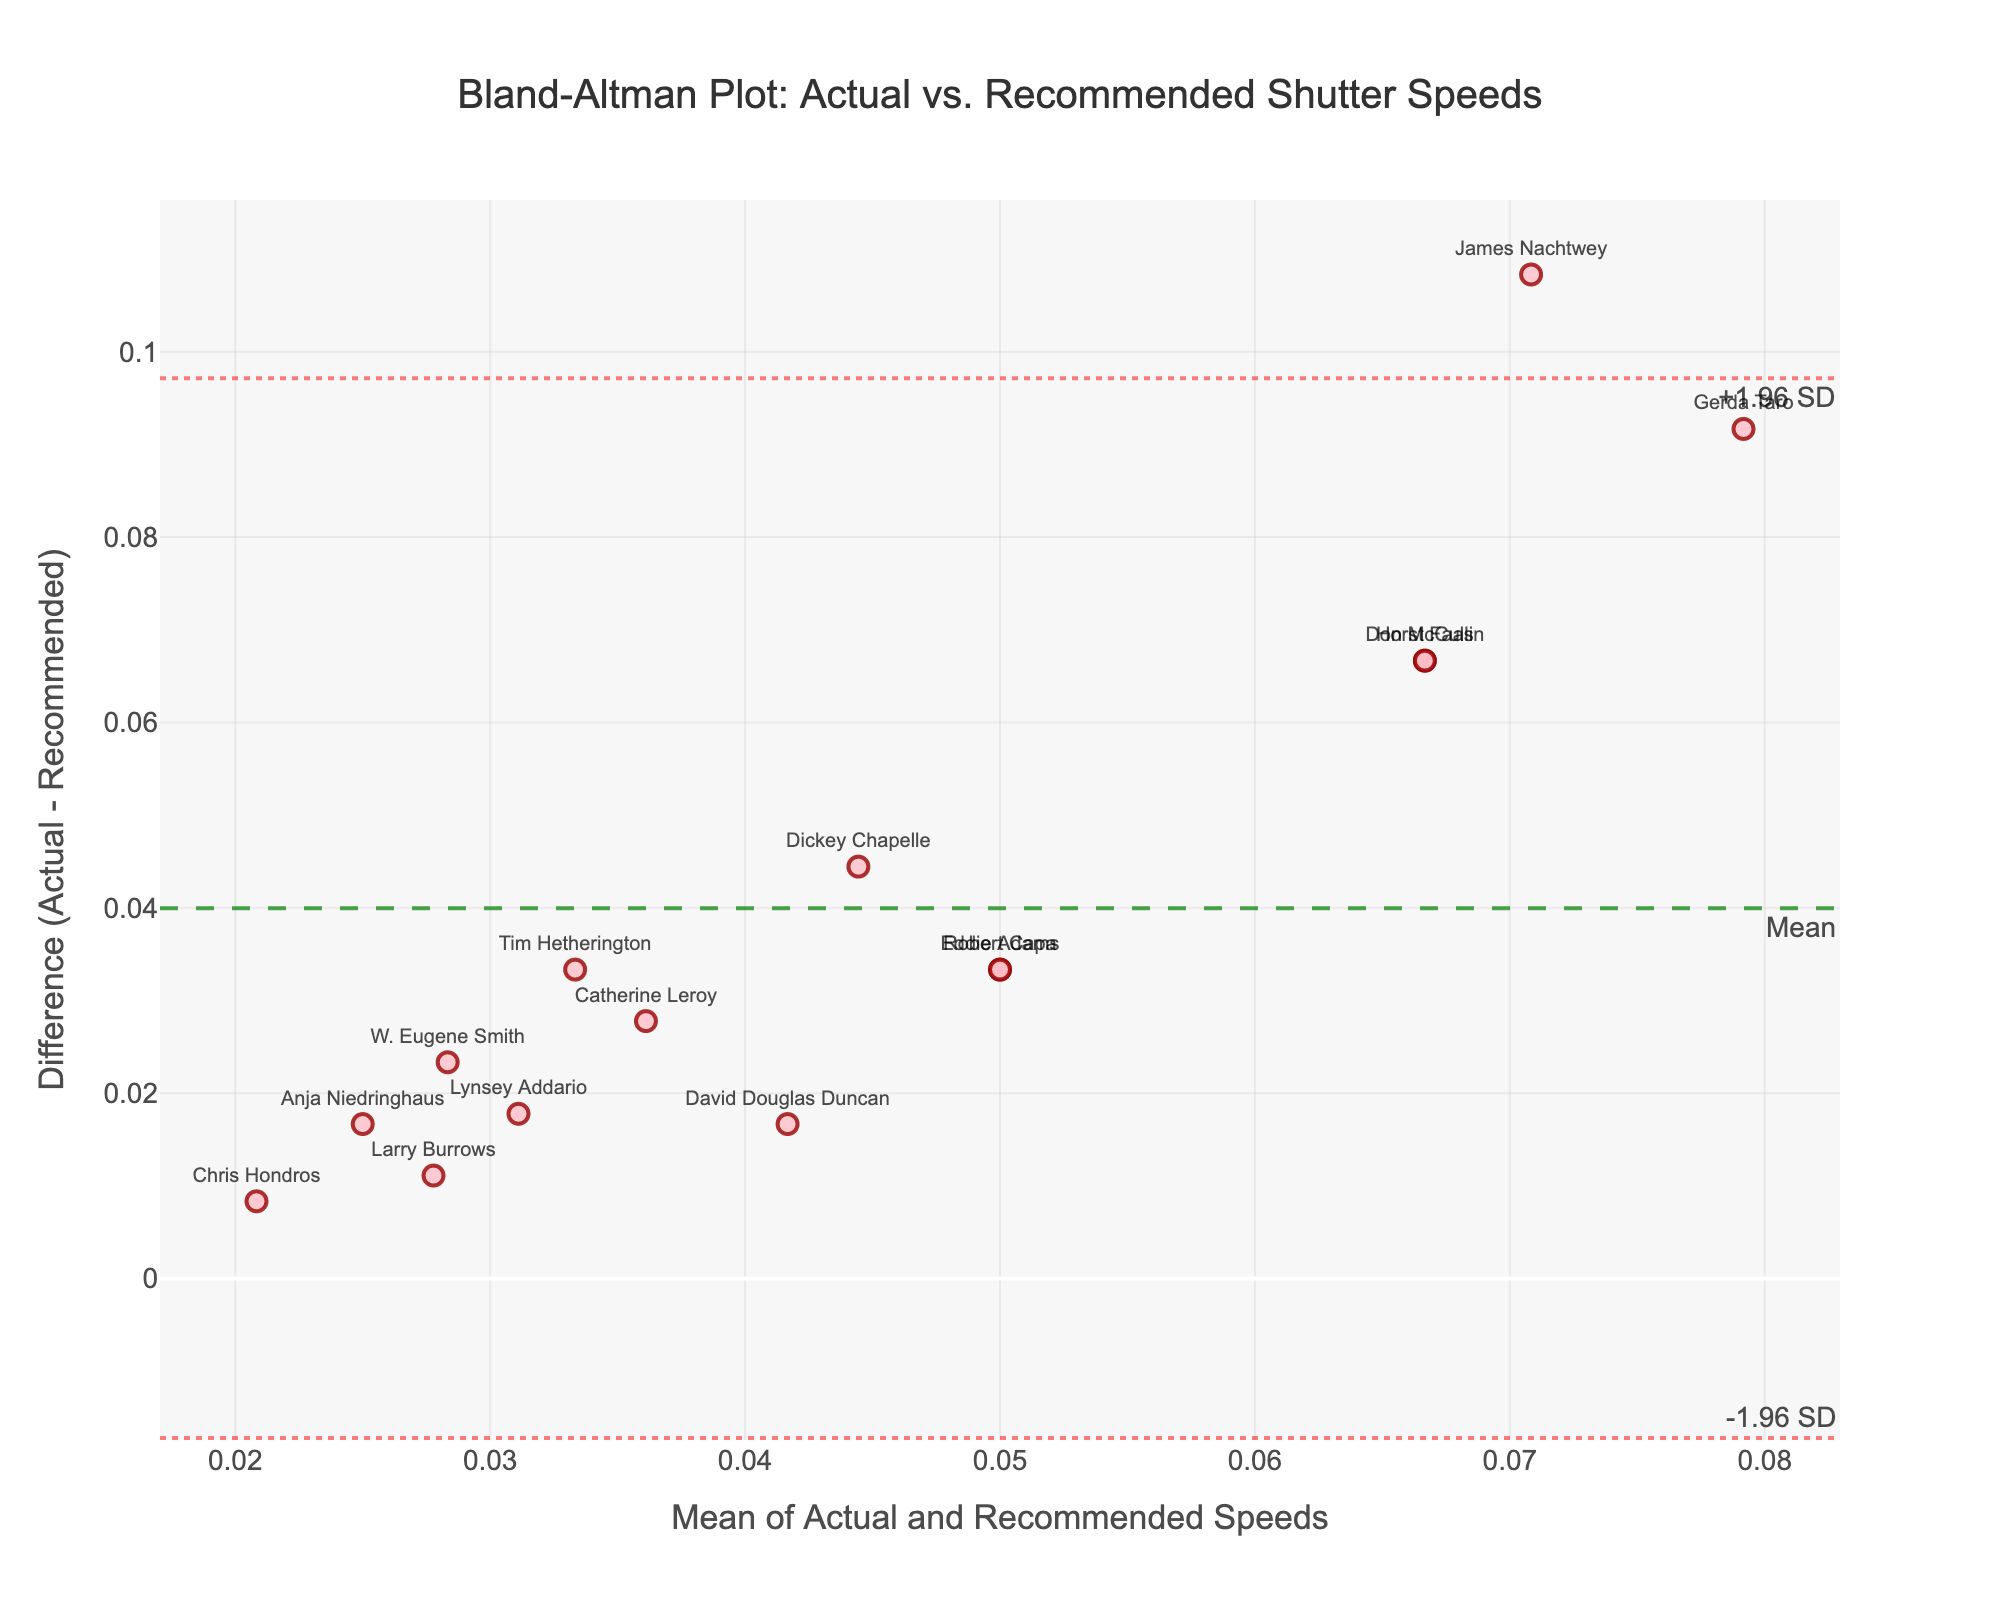How many data points are shown on the plot? Count the number of markers on the plot, each representing one photographer. There are 15 photographers listed in the data, so there should be 15 points.
Answer: 15 What do the dotted red lines represent on the plot? The dotted red lines are placed at mean difference ± 1.96 times the standard deviation of the differences, indicating the limits of agreement for the differences between the actual and recommended speeds.
Answer: Limits of agreement Who has the highest discrepancy between actual and recommended shutter speeds? Look at the y-axis to determine the point with the maximum positive or negative difference. James Nachtwey has a very high negative difference.
Answer: James Nachtwey Which photographer's point lies closest to the mean difference line? Identify the data point that is closest to the green dashed mean difference line, which represents the mean of the differences. Anja Niedringhaus appears closest.
Answer: Anja Niedringhaus What does a point above the mean difference line indicate? A point above the mean difference line means that the actual speed is greater than the recommended speed for that particular data point.
Answer: Actual speed is greater For whom is the difference between actual and recommended speeds zero? Locate which point exactly intersects the horizontal line at y=0. None of the points intersect at zero, indicating no one has a zero difference.
Answer: No one Which two photographers have the same mean shutter speed values, but different differences? Identify points with the same x-axis value but different y-axis values. Larry Burrows and Eddie Adams both have data points with a mean value around 0.025 but different differences.
Answer: Larry Burrows and Eddie Adams What is the mean value of the differences between actual and recommended speeds? The mean difference line, represented by the green dashed line, indicates the average difference between the actual and recommended speeds.
Answer: Around -0.03 If the mean of actual and recommended speeds is increased, what will happen to the plotted points? If the mean is increased for all photographers, points will shift right along the x-axis, but the differences and thus the y-axis values will not change.
Answer: Points will shift right What is the range between +1.96 SD and -1.96 SD lines? The range can be calculated by finding the difference between the upper (+1.96 SD) and lower (-1.96 SD) horizontal lines. This represents the spread within which 95% of the differences are expected to lie.
Answer: About 0.12 